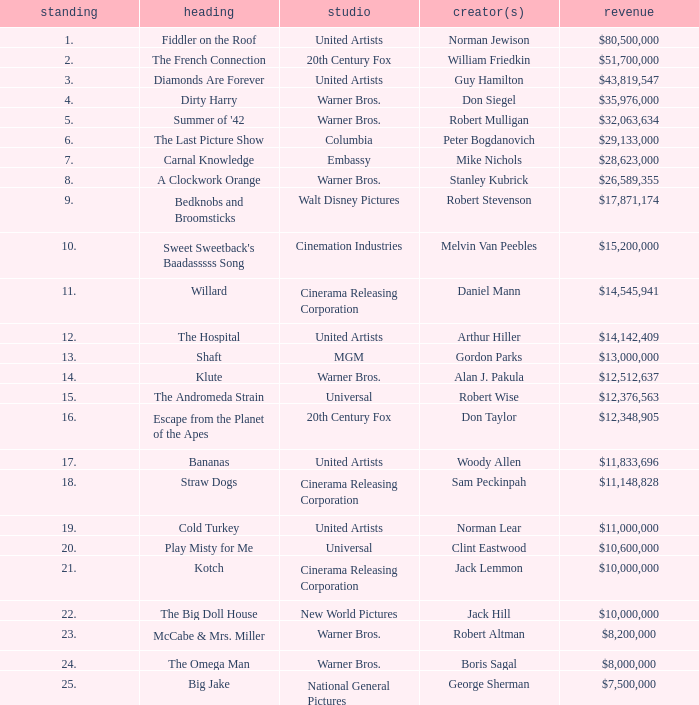What rank is the title with a gross of $26,589,355? 8.0. 